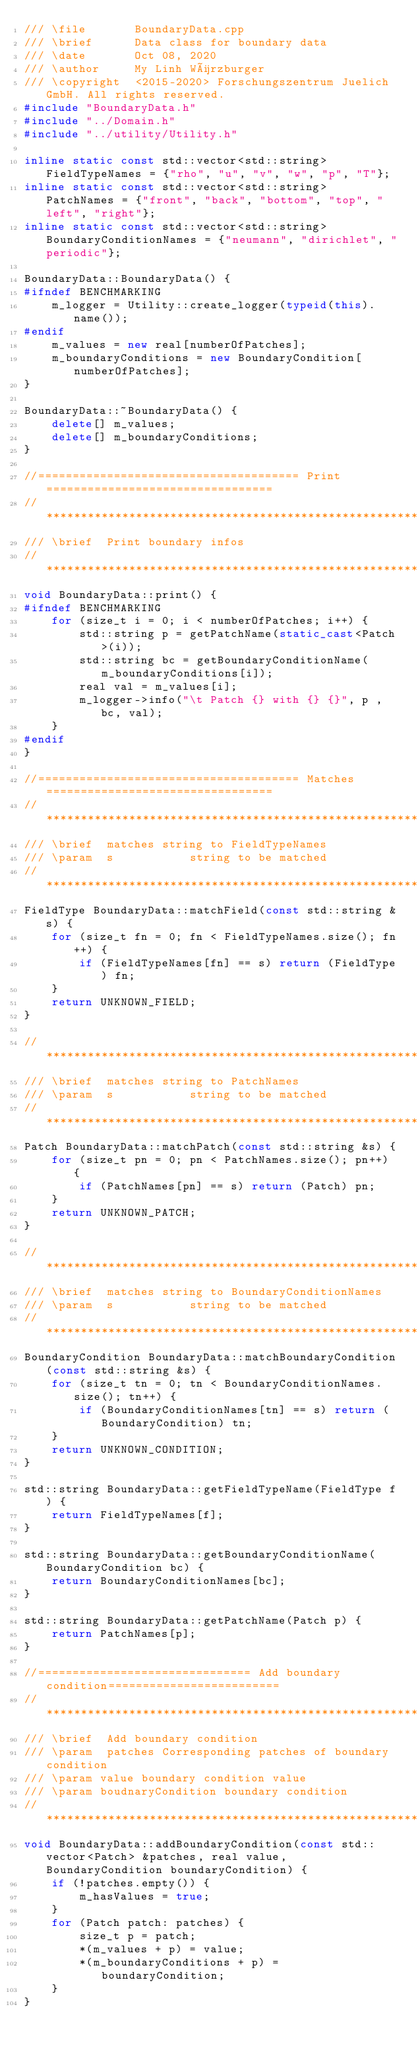<code> <loc_0><loc_0><loc_500><loc_500><_C++_>/// \file       BoundaryData.cpp
/// \brief      Data class for boundary data
/// \date       Oct 08, 2020
/// \author     My Linh Würzburger
/// \copyright  <2015-2020> Forschungszentrum Juelich GmbH. All rights reserved.
#include "BoundaryData.h"
#include "../Domain.h"
#include "../utility/Utility.h"

inline static const std::vector<std::string> FieldTypeNames = {"rho", "u", "v", "w", "p", "T"};
inline static const std::vector<std::string> PatchNames = {"front", "back", "bottom", "top", "left", "right"};
inline static const std::vector<std::string> BoundaryConditionNames = {"neumann", "dirichlet", "periodic"};

BoundaryData::BoundaryData() {
#ifndef BENCHMARKING
    m_logger = Utility::create_logger(typeid(this).name());
#endif
    m_values = new real[numberOfPatches];
    m_boundaryConditions = new BoundaryCondition[numberOfPatches];
}

BoundaryData::~BoundaryData() {
    delete[] m_values;
    delete[] m_boundaryConditions;
}

//====================================== Print =================================
// *******************************************************************************
/// \brief  Print boundary infos
// *******************************************************************************
void BoundaryData::print() {
#ifndef BENCHMARKING
    for (size_t i = 0; i < numberOfPatches; i++) {
        std::string p = getPatchName(static_cast<Patch>(i));
        std::string bc = getBoundaryConditionName(m_boundaryConditions[i]);
        real val = m_values[i];
        m_logger->info("\t Patch {} with {} {}", p , bc, val);
    }
#endif
}

//====================================== Matches =================================
// *******************************************************************************
/// \brief  matches string to FieldTypeNames
/// \param  s           string to be matched
// *******************************************************************************
FieldType BoundaryData::matchField(const std::string &s) {
    for (size_t fn = 0; fn < FieldTypeNames.size(); fn++) {
        if (FieldTypeNames[fn] == s) return (FieldType) fn;
    }
    return UNKNOWN_FIELD;
}

// *******************************************************************************
/// \brief  matches string to PatchNames
/// \param  s           string to be matched
// *******************************************************************************
Patch BoundaryData::matchPatch(const std::string &s) {
    for (size_t pn = 0; pn < PatchNames.size(); pn++) {
        if (PatchNames[pn] == s) return (Patch) pn;
    }
    return UNKNOWN_PATCH;
}

// *******************************************************************************
/// \brief  matches string to BoundaryConditionNames
/// \param  s           string to be matched
// *******************************************************************************
BoundaryCondition BoundaryData::matchBoundaryCondition(const std::string &s) {
    for (size_t tn = 0; tn < BoundaryConditionNames.size(); tn++) {
        if (BoundaryConditionNames[tn] == s) return (BoundaryCondition) tn;
    }
    return UNKNOWN_CONDITION;
}

std::string BoundaryData::getFieldTypeName(FieldType f) {
    return FieldTypeNames[f];
}

std::string BoundaryData::getBoundaryConditionName(BoundaryCondition bc) {
    return BoundaryConditionNames[bc];
}

std::string BoundaryData::getPatchName(Patch p) {
    return PatchNames[p];
}

//=============================== Add boundary condition=========================
// *******************************************************************************
/// \brief  Add boundary condition
/// \param  patches Corresponding patches of boundary condition
/// \param value boundary condition value
/// \param boudnaryCondition boundary condition
// *******************************************************************************
void BoundaryData::addBoundaryCondition(const std::vector<Patch> &patches, real value, BoundaryCondition boundaryCondition) {
    if (!patches.empty()) {
        m_hasValues = true;
    }
    for (Patch patch: patches) {
        size_t p = patch;
        *(m_values + p) = value;
        *(m_boundaryConditions + p) = boundaryCondition;
    }
}
</code> 